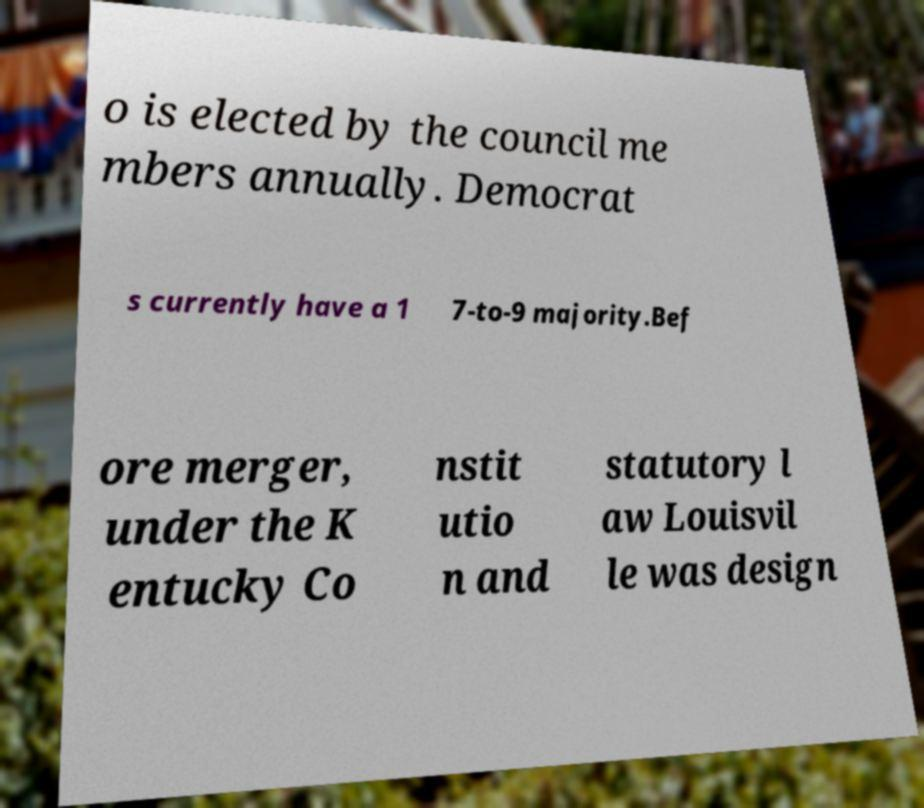Could you assist in decoding the text presented in this image and type it out clearly? o is elected by the council me mbers annually. Democrat s currently have a 1 7-to-9 majority.Bef ore merger, under the K entucky Co nstit utio n and statutory l aw Louisvil le was design 